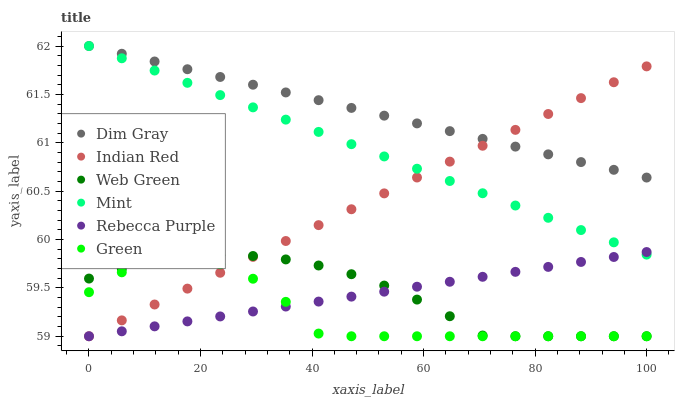Does Green have the minimum area under the curve?
Answer yes or no. Yes. Does Dim Gray have the maximum area under the curve?
Answer yes or no. Yes. Does Web Green have the minimum area under the curve?
Answer yes or no. No. Does Web Green have the maximum area under the curve?
Answer yes or no. No. Is Indian Red the smoothest?
Answer yes or no. Yes. Is Green the roughest?
Answer yes or no. Yes. Is Web Green the smoothest?
Answer yes or no. No. Is Web Green the roughest?
Answer yes or no. No. Does Web Green have the lowest value?
Answer yes or no. Yes. Does Mint have the lowest value?
Answer yes or no. No. Does Mint have the highest value?
Answer yes or no. Yes. Does Web Green have the highest value?
Answer yes or no. No. Is Green less than Dim Gray?
Answer yes or no. Yes. Is Mint greater than Web Green?
Answer yes or no. Yes. Does Web Green intersect Rebecca Purple?
Answer yes or no. Yes. Is Web Green less than Rebecca Purple?
Answer yes or no. No. Is Web Green greater than Rebecca Purple?
Answer yes or no. No. Does Green intersect Dim Gray?
Answer yes or no. No. 